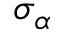<formula> <loc_0><loc_0><loc_500><loc_500>\sigma _ { \alpha }</formula> 